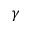<formula> <loc_0><loc_0><loc_500><loc_500>\gamma</formula> 